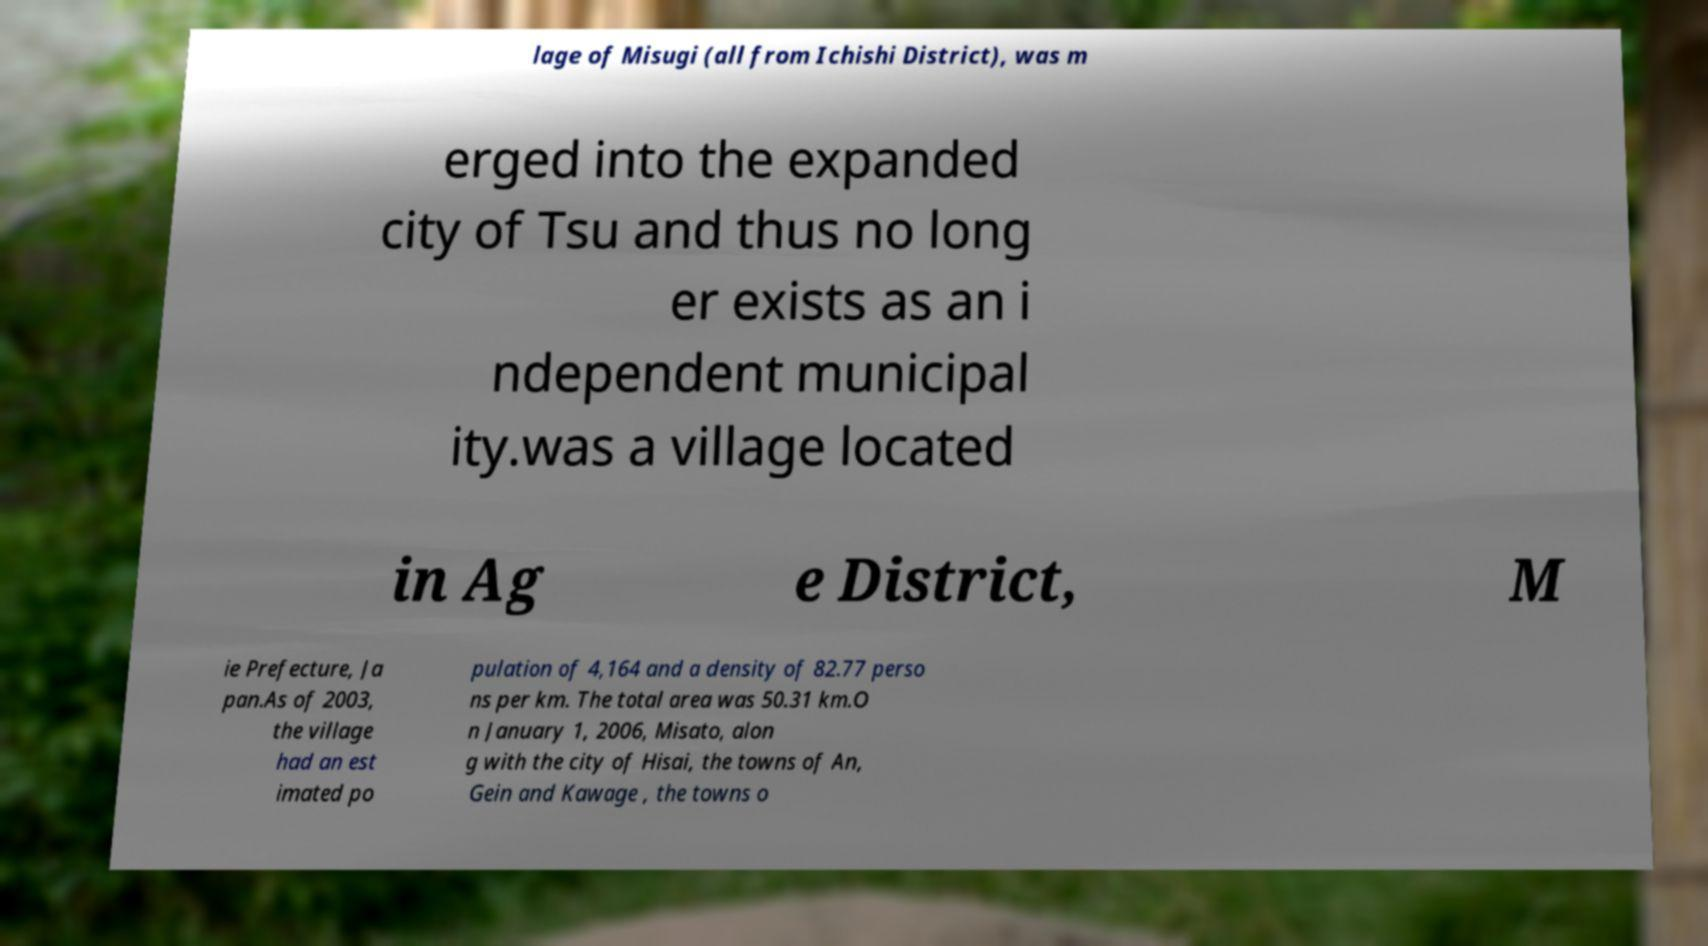Please identify and transcribe the text found in this image. lage of Misugi (all from Ichishi District), was m erged into the expanded city of Tsu and thus no long er exists as an i ndependent municipal ity.was a village located in Ag e District, M ie Prefecture, Ja pan.As of 2003, the village had an est imated po pulation of 4,164 and a density of 82.77 perso ns per km. The total area was 50.31 km.O n January 1, 2006, Misato, alon g with the city of Hisai, the towns of An, Gein and Kawage , the towns o 